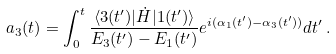<formula> <loc_0><loc_0><loc_500><loc_500>a _ { 3 } ( t ) = \int _ { 0 } ^ { t } \frac { \langle 3 ( t ^ { \prime } ) | \dot { H } | 1 ( t ^ { \prime } ) \rangle } { E _ { 3 } ( t ^ { \prime } ) - E _ { 1 } ( t ^ { \prime } ) } e ^ { i ( \alpha _ { 1 } ( t ^ { \prime } ) - \alpha _ { 3 } ( t ^ { \prime } ) ) } d t ^ { \prime } \, .</formula> 